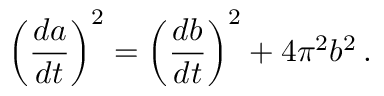Convert formula to latex. <formula><loc_0><loc_0><loc_500><loc_500>\left ( { \frac { d a } { d t } } \right ) ^ { 2 } = \left ( { \frac { d b } { d t } } \right ) ^ { 2 } + 4 \pi ^ { 2 } b ^ { 2 } \, .</formula> 